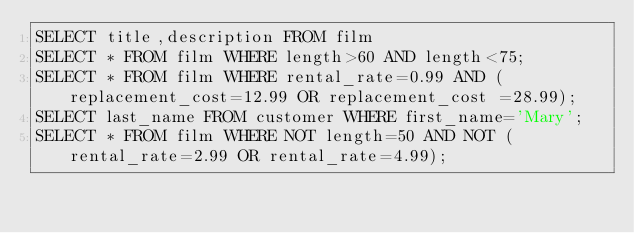<code> <loc_0><loc_0><loc_500><loc_500><_SQL_>SELECT title,description FROM film
SELECT * FROM film WHERE length>60 AND length<75;
SELECT * FROM film WHERE rental_rate=0.99 AND (replacement_cost=12.99 OR replacement_cost =28.99);
SELECT last_name FROM customer WHERE first_name='Mary';
SELECT * FROM film WHERE NOT length=50 AND NOT (rental_rate=2.99 OR rental_rate=4.99);
</code> 